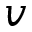<formula> <loc_0><loc_0><loc_500><loc_500>v</formula> 